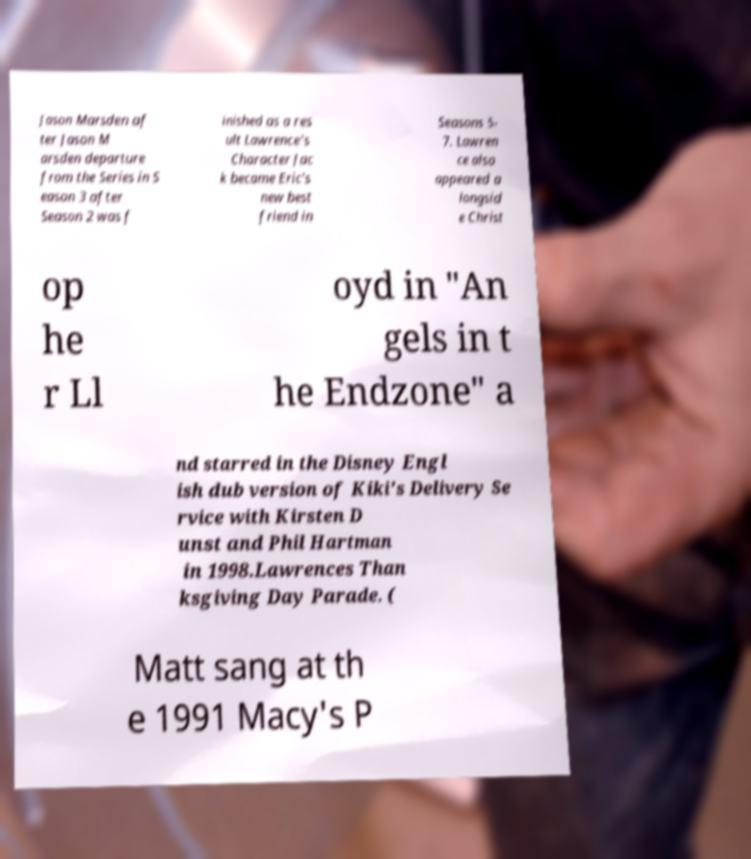There's text embedded in this image that I need extracted. Can you transcribe it verbatim? Jason Marsden af ter Jason M arsden departure from the Series in S eason 3 after Season 2 was f inished as a res ult Lawrence's Character Jac k became Eric's new best friend in Seasons 5- 7. Lawren ce also appeared a longsid e Christ op he r Ll oyd in "An gels in t he Endzone" a nd starred in the Disney Engl ish dub version of Kiki's Delivery Se rvice with Kirsten D unst and Phil Hartman in 1998.Lawrences Than ksgiving Day Parade. ( Matt sang at th e 1991 Macy's P 